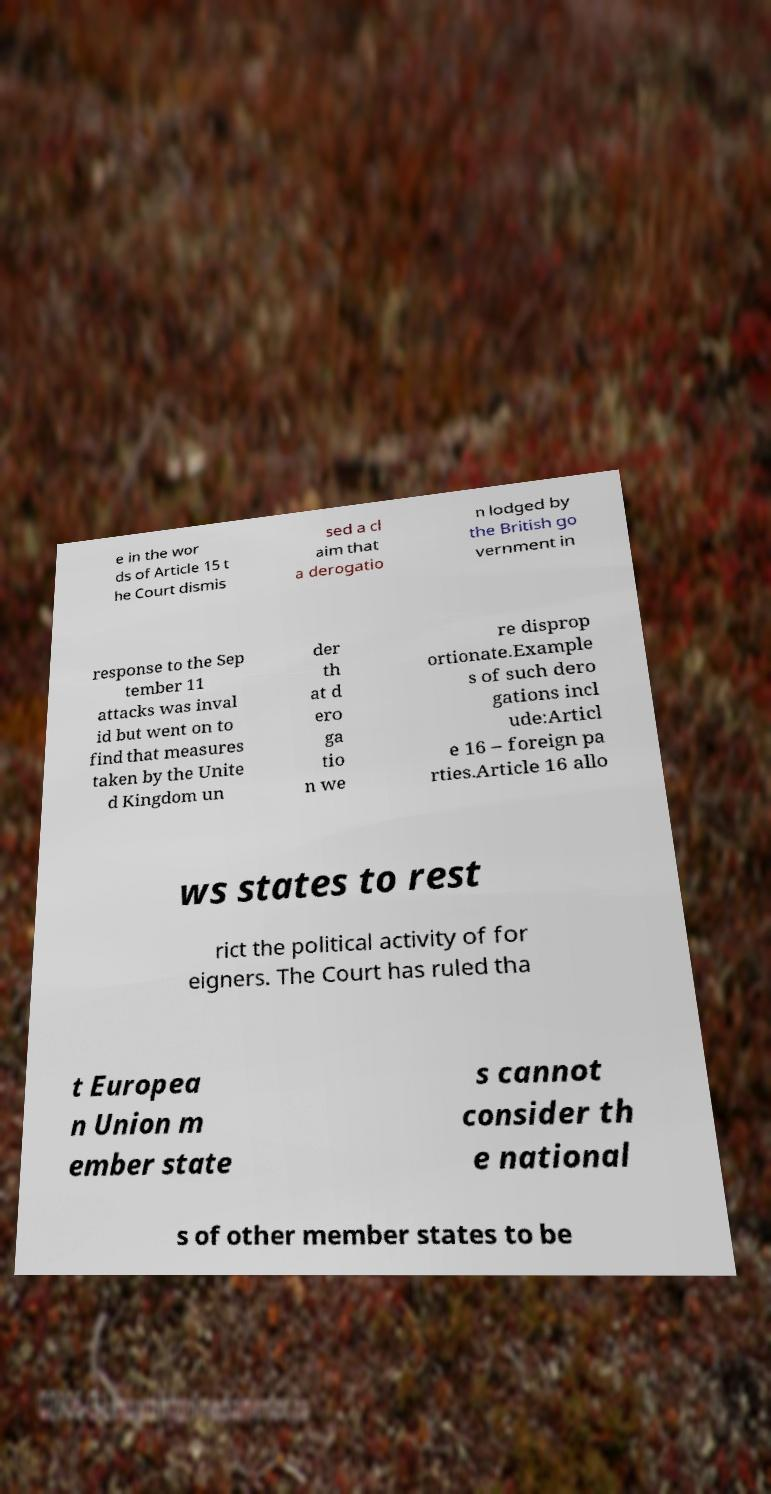For documentation purposes, I need the text within this image transcribed. Could you provide that? e in the wor ds of Article 15 t he Court dismis sed a cl aim that a derogatio n lodged by the British go vernment in response to the Sep tember 11 attacks was inval id but went on to find that measures taken by the Unite d Kingdom un der th at d ero ga tio n we re disprop ortionate.Example s of such dero gations incl ude:Articl e 16 – foreign pa rties.Article 16 allo ws states to rest rict the political activity of for eigners. The Court has ruled tha t Europea n Union m ember state s cannot consider th e national s of other member states to be 